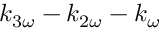<formula> <loc_0><loc_0><loc_500><loc_500>k _ { 3 \omega } - k _ { 2 \omega } - k _ { \omega }</formula> 